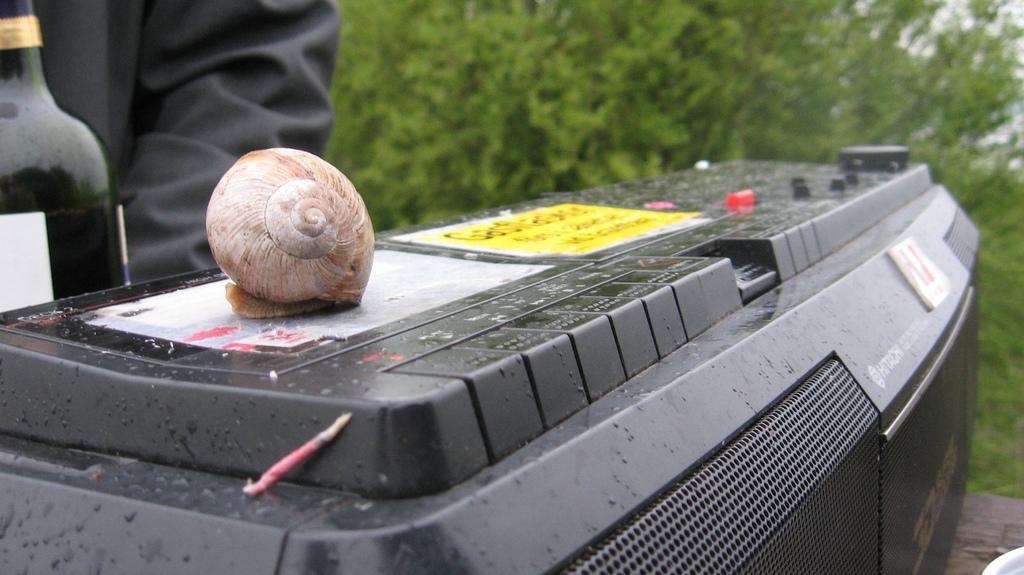How would you summarize this image in a sentence or two? In the center of the image there is a shell on the tape recorder. On the left side of the image we can see bottle. In the background there are plants. 